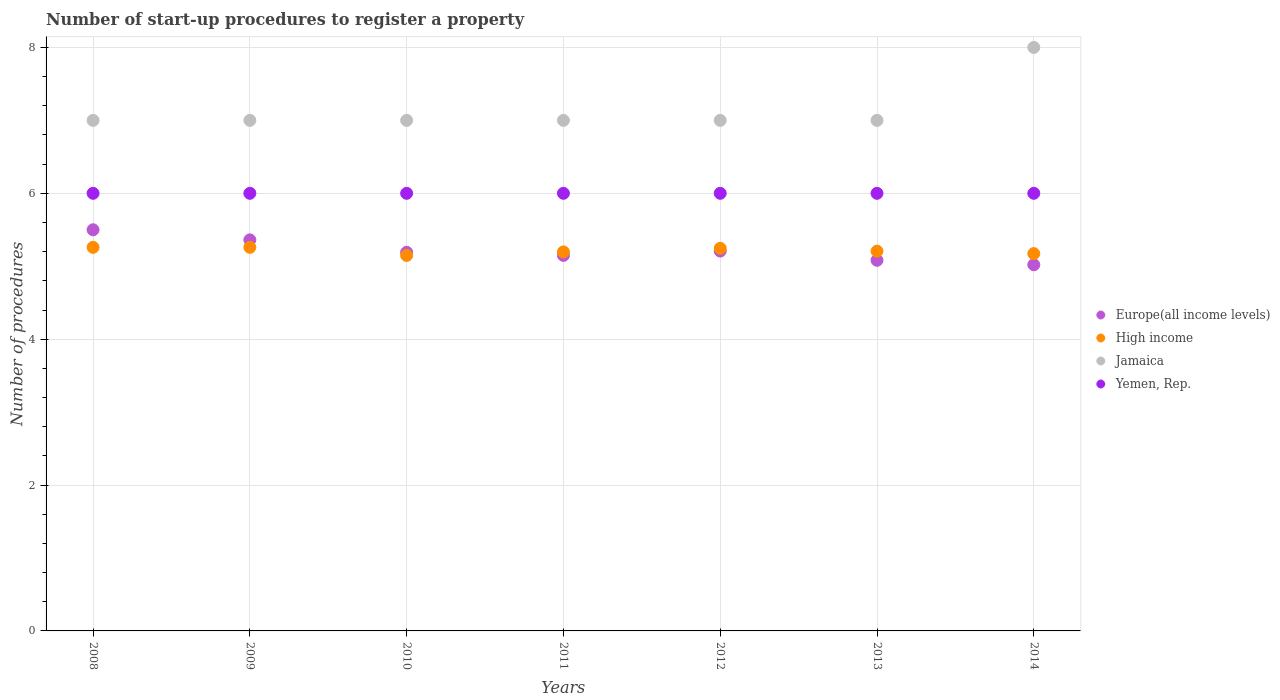What is the number of procedures required to register a property in High income in 2012?
Give a very brief answer. 5.25. Across all years, what is the maximum number of procedures required to register a property in Jamaica?
Your answer should be very brief. 8. Across all years, what is the minimum number of procedures required to register a property in Jamaica?
Your answer should be compact. 7. In which year was the number of procedures required to register a property in Europe(all income levels) maximum?
Your answer should be very brief. 2008. What is the total number of procedures required to register a property in Yemen, Rep. in the graph?
Keep it short and to the point. 42. What is the difference between the number of procedures required to register a property in Yemen, Rep. in 2010 and that in 2013?
Provide a short and direct response. 0. What is the difference between the number of procedures required to register a property in Jamaica in 2014 and the number of procedures required to register a property in High income in 2008?
Provide a short and direct response. 2.74. What is the average number of procedures required to register a property in High income per year?
Ensure brevity in your answer.  5.21. In the year 2009, what is the difference between the number of procedures required to register a property in Europe(all income levels) and number of procedures required to register a property in Jamaica?
Give a very brief answer. -1.64. What is the ratio of the number of procedures required to register a property in High income in 2012 to that in 2014?
Keep it short and to the point. 1.01. Is the number of procedures required to register a property in Yemen, Rep. in 2008 less than that in 2011?
Ensure brevity in your answer.  No. What is the difference between the highest and the second highest number of procedures required to register a property in High income?
Offer a terse response. 0. In how many years, is the number of procedures required to register a property in Europe(all income levels) greater than the average number of procedures required to register a property in Europe(all income levels) taken over all years?
Provide a succinct answer. 2. Does the number of procedures required to register a property in Europe(all income levels) monotonically increase over the years?
Provide a short and direct response. No. How many years are there in the graph?
Ensure brevity in your answer.  7. What is the title of the graph?
Ensure brevity in your answer.  Number of start-up procedures to register a property. Does "Zambia" appear as one of the legend labels in the graph?
Provide a succinct answer. No. What is the label or title of the X-axis?
Offer a terse response. Years. What is the label or title of the Y-axis?
Keep it short and to the point. Number of procedures. What is the Number of procedures in Europe(all income levels) in 2008?
Give a very brief answer. 5.5. What is the Number of procedures in High income in 2008?
Provide a short and direct response. 5.26. What is the Number of procedures in Jamaica in 2008?
Ensure brevity in your answer.  7. What is the Number of procedures of Yemen, Rep. in 2008?
Your response must be concise. 6. What is the Number of procedures in Europe(all income levels) in 2009?
Your response must be concise. 5.36. What is the Number of procedures of High income in 2009?
Keep it short and to the point. 5.26. What is the Number of procedures of Europe(all income levels) in 2010?
Keep it short and to the point. 5.19. What is the Number of procedures in High income in 2010?
Make the answer very short. 5.15. What is the Number of procedures in Europe(all income levels) in 2011?
Your response must be concise. 5.15. What is the Number of procedures in High income in 2011?
Ensure brevity in your answer.  5.2. What is the Number of procedures of Yemen, Rep. in 2011?
Give a very brief answer. 6. What is the Number of procedures of Europe(all income levels) in 2012?
Your answer should be very brief. 5.21. What is the Number of procedures of High income in 2012?
Keep it short and to the point. 5.25. What is the Number of procedures of Jamaica in 2012?
Give a very brief answer. 7. What is the Number of procedures in Yemen, Rep. in 2012?
Offer a very short reply. 6. What is the Number of procedures of Europe(all income levels) in 2013?
Your answer should be very brief. 5.08. What is the Number of procedures in High income in 2013?
Your answer should be compact. 5.21. What is the Number of procedures of Yemen, Rep. in 2013?
Your response must be concise. 6. What is the Number of procedures of Europe(all income levels) in 2014?
Provide a short and direct response. 5.02. What is the Number of procedures in High income in 2014?
Give a very brief answer. 5.17. Across all years, what is the maximum Number of procedures in Europe(all income levels)?
Provide a short and direct response. 5.5. Across all years, what is the maximum Number of procedures of High income?
Provide a short and direct response. 5.26. Across all years, what is the maximum Number of procedures in Yemen, Rep.?
Give a very brief answer. 6. Across all years, what is the minimum Number of procedures of Europe(all income levels)?
Offer a very short reply. 5.02. Across all years, what is the minimum Number of procedures in High income?
Your answer should be compact. 5.15. Across all years, what is the minimum Number of procedures of Yemen, Rep.?
Your answer should be very brief. 6. What is the total Number of procedures of Europe(all income levels) in the graph?
Offer a terse response. 36.51. What is the total Number of procedures of High income in the graph?
Your response must be concise. 36.49. What is the difference between the Number of procedures in Europe(all income levels) in 2008 and that in 2009?
Make the answer very short. 0.14. What is the difference between the Number of procedures in High income in 2008 and that in 2009?
Your answer should be very brief. 0. What is the difference between the Number of procedures of Jamaica in 2008 and that in 2009?
Make the answer very short. 0. What is the difference between the Number of procedures in Europe(all income levels) in 2008 and that in 2010?
Ensure brevity in your answer.  0.31. What is the difference between the Number of procedures of High income in 2008 and that in 2010?
Provide a succinct answer. 0.11. What is the difference between the Number of procedures of Jamaica in 2008 and that in 2010?
Provide a succinct answer. 0. What is the difference between the Number of procedures in Yemen, Rep. in 2008 and that in 2010?
Offer a very short reply. 0. What is the difference between the Number of procedures in Europe(all income levels) in 2008 and that in 2011?
Make the answer very short. 0.35. What is the difference between the Number of procedures of High income in 2008 and that in 2011?
Ensure brevity in your answer.  0.06. What is the difference between the Number of procedures of Yemen, Rep. in 2008 and that in 2011?
Ensure brevity in your answer.  0. What is the difference between the Number of procedures of Europe(all income levels) in 2008 and that in 2012?
Give a very brief answer. 0.29. What is the difference between the Number of procedures in High income in 2008 and that in 2012?
Provide a succinct answer. 0.01. What is the difference between the Number of procedures of Yemen, Rep. in 2008 and that in 2012?
Ensure brevity in your answer.  0. What is the difference between the Number of procedures of Europe(all income levels) in 2008 and that in 2013?
Your response must be concise. 0.42. What is the difference between the Number of procedures of High income in 2008 and that in 2013?
Make the answer very short. 0.05. What is the difference between the Number of procedures of Jamaica in 2008 and that in 2013?
Your answer should be compact. 0. What is the difference between the Number of procedures of Yemen, Rep. in 2008 and that in 2013?
Ensure brevity in your answer.  0. What is the difference between the Number of procedures in Europe(all income levels) in 2008 and that in 2014?
Your answer should be very brief. 0.48. What is the difference between the Number of procedures in High income in 2008 and that in 2014?
Make the answer very short. 0.09. What is the difference between the Number of procedures of Jamaica in 2008 and that in 2014?
Offer a terse response. -1. What is the difference between the Number of procedures in Yemen, Rep. in 2008 and that in 2014?
Provide a succinct answer. 0. What is the difference between the Number of procedures of Europe(all income levels) in 2009 and that in 2010?
Your response must be concise. 0.17. What is the difference between the Number of procedures of High income in 2009 and that in 2010?
Your answer should be very brief. 0.11. What is the difference between the Number of procedures of Jamaica in 2009 and that in 2010?
Provide a succinct answer. 0. What is the difference between the Number of procedures of Yemen, Rep. in 2009 and that in 2010?
Make the answer very short. 0. What is the difference between the Number of procedures in Europe(all income levels) in 2009 and that in 2011?
Offer a very short reply. 0.21. What is the difference between the Number of procedures of High income in 2009 and that in 2011?
Make the answer very short. 0.06. What is the difference between the Number of procedures of Jamaica in 2009 and that in 2011?
Provide a short and direct response. 0. What is the difference between the Number of procedures of Europe(all income levels) in 2009 and that in 2012?
Provide a succinct answer. 0.15. What is the difference between the Number of procedures of High income in 2009 and that in 2012?
Provide a short and direct response. 0.01. What is the difference between the Number of procedures in Yemen, Rep. in 2009 and that in 2012?
Provide a short and direct response. 0. What is the difference between the Number of procedures in Europe(all income levels) in 2009 and that in 2013?
Offer a very short reply. 0.28. What is the difference between the Number of procedures of High income in 2009 and that in 2013?
Your answer should be compact. 0.05. What is the difference between the Number of procedures in Europe(all income levels) in 2009 and that in 2014?
Your answer should be very brief. 0.34. What is the difference between the Number of procedures in High income in 2009 and that in 2014?
Keep it short and to the point. 0.09. What is the difference between the Number of procedures of Yemen, Rep. in 2009 and that in 2014?
Your response must be concise. 0. What is the difference between the Number of procedures in Europe(all income levels) in 2010 and that in 2011?
Your answer should be compact. 0.04. What is the difference between the Number of procedures of High income in 2010 and that in 2011?
Offer a terse response. -0.05. What is the difference between the Number of procedures of Yemen, Rep. in 2010 and that in 2011?
Provide a succinct answer. 0. What is the difference between the Number of procedures of Europe(all income levels) in 2010 and that in 2012?
Your answer should be compact. -0.02. What is the difference between the Number of procedures in High income in 2010 and that in 2012?
Ensure brevity in your answer.  -0.1. What is the difference between the Number of procedures of Yemen, Rep. in 2010 and that in 2012?
Provide a short and direct response. 0. What is the difference between the Number of procedures of Europe(all income levels) in 2010 and that in 2013?
Make the answer very short. 0.11. What is the difference between the Number of procedures in High income in 2010 and that in 2013?
Provide a short and direct response. -0.06. What is the difference between the Number of procedures of Jamaica in 2010 and that in 2013?
Offer a very short reply. 0. What is the difference between the Number of procedures in Yemen, Rep. in 2010 and that in 2013?
Keep it short and to the point. 0. What is the difference between the Number of procedures in Europe(all income levels) in 2010 and that in 2014?
Offer a terse response. 0.17. What is the difference between the Number of procedures in High income in 2010 and that in 2014?
Give a very brief answer. -0.03. What is the difference between the Number of procedures of Yemen, Rep. in 2010 and that in 2014?
Keep it short and to the point. 0. What is the difference between the Number of procedures of Europe(all income levels) in 2011 and that in 2012?
Your answer should be very brief. -0.06. What is the difference between the Number of procedures of High income in 2011 and that in 2012?
Provide a succinct answer. -0.05. What is the difference between the Number of procedures of Europe(all income levels) in 2011 and that in 2013?
Offer a terse response. 0.07. What is the difference between the Number of procedures in High income in 2011 and that in 2013?
Your answer should be compact. -0.01. What is the difference between the Number of procedures in Yemen, Rep. in 2011 and that in 2013?
Offer a very short reply. 0. What is the difference between the Number of procedures in Europe(all income levels) in 2011 and that in 2014?
Make the answer very short. 0.13. What is the difference between the Number of procedures in High income in 2011 and that in 2014?
Provide a short and direct response. 0.02. What is the difference between the Number of procedures in Jamaica in 2011 and that in 2014?
Provide a short and direct response. -1. What is the difference between the Number of procedures of Yemen, Rep. in 2011 and that in 2014?
Give a very brief answer. 0. What is the difference between the Number of procedures in Europe(all income levels) in 2012 and that in 2013?
Make the answer very short. 0.13. What is the difference between the Number of procedures of High income in 2012 and that in 2013?
Your answer should be very brief. 0.04. What is the difference between the Number of procedures of Yemen, Rep. in 2012 and that in 2013?
Your answer should be compact. 0. What is the difference between the Number of procedures in Europe(all income levels) in 2012 and that in 2014?
Offer a terse response. 0.19. What is the difference between the Number of procedures in High income in 2012 and that in 2014?
Your answer should be very brief. 0.07. What is the difference between the Number of procedures in Europe(all income levels) in 2013 and that in 2014?
Provide a succinct answer. 0.06. What is the difference between the Number of procedures in Yemen, Rep. in 2013 and that in 2014?
Make the answer very short. 0. What is the difference between the Number of procedures of Europe(all income levels) in 2008 and the Number of procedures of High income in 2009?
Ensure brevity in your answer.  0.24. What is the difference between the Number of procedures of Europe(all income levels) in 2008 and the Number of procedures of Jamaica in 2009?
Keep it short and to the point. -1.5. What is the difference between the Number of procedures of High income in 2008 and the Number of procedures of Jamaica in 2009?
Provide a succinct answer. -1.74. What is the difference between the Number of procedures of High income in 2008 and the Number of procedures of Yemen, Rep. in 2009?
Your response must be concise. -0.74. What is the difference between the Number of procedures in Europe(all income levels) in 2008 and the Number of procedures in High income in 2010?
Your answer should be compact. 0.35. What is the difference between the Number of procedures in Europe(all income levels) in 2008 and the Number of procedures in Jamaica in 2010?
Keep it short and to the point. -1.5. What is the difference between the Number of procedures in Europe(all income levels) in 2008 and the Number of procedures in Yemen, Rep. in 2010?
Offer a very short reply. -0.5. What is the difference between the Number of procedures of High income in 2008 and the Number of procedures of Jamaica in 2010?
Offer a very short reply. -1.74. What is the difference between the Number of procedures of High income in 2008 and the Number of procedures of Yemen, Rep. in 2010?
Ensure brevity in your answer.  -0.74. What is the difference between the Number of procedures of Jamaica in 2008 and the Number of procedures of Yemen, Rep. in 2010?
Offer a terse response. 1. What is the difference between the Number of procedures of Europe(all income levels) in 2008 and the Number of procedures of High income in 2011?
Your response must be concise. 0.3. What is the difference between the Number of procedures in Europe(all income levels) in 2008 and the Number of procedures in Jamaica in 2011?
Provide a succinct answer. -1.5. What is the difference between the Number of procedures of Europe(all income levels) in 2008 and the Number of procedures of Yemen, Rep. in 2011?
Offer a very short reply. -0.5. What is the difference between the Number of procedures in High income in 2008 and the Number of procedures in Jamaica in 2011?
Make the answer very short. -1.74. What is the difference between the Number of procedures in High income in 2008 and the Number of procedures in Yemen, Rep. in 2011?
Offer a very short reply. -0.74. What is the difference between the Number of procedures of Europe(all income levels) in 2008 and the Number of procedures of High income in 2012?
Provide a short and direct response. 0.25. What is the difference between the Number of procedures in Europe(all income levels) in 2008 and the Number of procedures in Jamaica in 2012?
Give a very brief answer. -1.5. What is the difference between the Number of procedures in Europe(all income levels) in 2008 and the Number of procedures in Yemen, Rep. in 2012?
Ensure brevity in your answer.  -0.5. What is the difference between the Number of procedures of High income in 2008 and the Number of procedures of Jamaica in 2012?
Offer a very short reply. -1.74. What is the difference between the Number of procedures in High income in 2008 and the Number of procedures in Yemen, Rep. in 2012?
Make the answer very short. -0.74. What is the difference between the Number of procedures in Jamaica in 2008 and the Number of procedures in Yemen, Rep. in 2012?
Your answer should be compact. 1. What is the difference between the Number of procedures of Europe(all income levels) in 2008 and the Number of procedures of High income in 2013?
Your answer should be compact. 0.29. What is the difference between the Number of procedures in Europe(all income levels) in 2008 and the Number of procedures in Yemen, Rep. in 2013?
Your response must be concise. -0.5. What is the difference between the Number of procedures of High income in 2008 and the Number of procedures of Jamaica in 2013?
Ensure brevity in your answer.  -1.74. What is the difference between the Number of procedures in High income in 2008 and the Number of procedures in Yemen, Rep. in 2013?
Provide a succinct answer. -0.74. What is the difference between the Number of procedures of Jamaica in 2008 and the Number of procedures of Yemen, Rep. in 2013?
Ensure brevity in your answer.  1. What is the difference between the Number of procedures in Europe(all income levels) in 2008 and the Number of procedures in High income in 2014?
Keep it short and to the point. 0.33. What is the difference between the Number of procedures of Europe(all income levels) in 2008 and the Number of procedures of Yemen, Rep. in 2014?
Your response must be concise. -0.5. What is the difference between the Number of procedures in High income in 2008 and the Number of procedures in Jamaica in 2014?
Offer a terse response. -2.74. What is the difference between the Number of procedures in High income in 2008 and the Number of procedures in Yemen, Rep. in 2014?
Your response must be concise. -0.74. What is the difference between the Number of procedures in Europe(all income levels) in 2009 and the Number of procedures in High income in 2010?
Offer a terse response. 0.21. What is the difference between the Number of procedures in Europe(all income levels) in 2009 and the Number of procedures in Jamaica in 2010?
Provide a succinct answer. -1.64. What is the difference between the Number of procedures of Europe(all income levels) in 2009 and the Number of procedures of Yemen, Rep. in 2010?
Keep it short and to the point. -0.64. What is the difference between the Number of procedures in High income in 2009 and the Number of procedures in Jamaica in 2010?
Your answer should be compact. -1.74. What is the difference between the Number of procedures in High income in 2009 and the Number of procedures in Yemen, Rep. in 2010?
Ensure brevity in your answer.  -0.74. What is the difference between the Number of procedures in Europe(all income levels) in 2009 and the Number of procedures in High income in 2011?
Provide a short and direct response. 0.17. What is the difference between the Number of procedures of Europe(all income levels) in 2009 and the Number of procedures of Jamaica in 2011?
Offer a terse response. -1.64. What is the difference between the Number of procedures in Europe(all income levels) in 2009 and the Number of procedures in Yemen, Rep. in 2011?
Give a very brief answer. -0.64. What is the difference between the Number of procedures in High income in 2009 and the Number of procedures in Jamaica in 2011?
Make the answer very short. -1.74. What is the difference between the Number of procedures in High income in 2009 and the Number of procedures in Yemen, Rep. in 2011?
Your response must be concise. -0.74. What is the difference between the Number of procedures in Jamaica in 2009 and the Number of procedures in Yemen, Rep. in 2011?
Offer a terse response. 1. What is the difference between the Number of procedures in Europe(all income levels) in 2009 and the Number of procedures in High income in 2012?
Your answer should be very brief. 0.12. What is the difference between the Number of procedures of Europe(all income levels) in 2009 and the Number of procedures of Jamaica in 2012?
Keep it short and to the point. -1.64. What is the difference between the Number of procedures of Europe(all income levels) in 2009 and the Number of procedures of Yemen, Rep. in 2012?
Your response must be concise. -0.64. What is the difference between the Number of procedures of High income in 2009 and the Number of procedures of Jamaica in 2012?
Offer a very short reply. -1.74. What is the difference between the Number of procedures in High income in 2009 and the Number of procedures in Yemen, Rep. in 2012?
Keep it short and to the point. -0.74. What is the difference between the Number of procedures in Jamaica in 2009 and the Number of procedures in Yemen, Rep. in 2012?
Offer a very short reply. 1. What is the difference between the Number of procedures of Europe(all income levels) in 2009 and the Number of procedures of High income in 2013?
Your answer should be compact. 0.15. What is the difference between the Number of procedures in Europe(all income levels) in 2009 and the Number of procedures in Jamaica in 2013?
Offer a terse response. -1.64. What is the difference between the Number of procedures of Europe(all income levels) in 2009 and the Number of procedures of Yemen, Rep. in 2013?
Provide a succinct answer. -0.64. What is the difference between the Number of procedures of High income in 2009 and the Number of procedures of Jamaica in 2013?
Your answer should be very brief. -1.74. What is the difference between the Number of procedures in High income in 2009 and the Number of procedures in Yemen, Rep. in 2013?
Your response must be concise. -0.74. What is the difference between the Number of procedures in Jamaica in 2009 and the Number of procedures in Yemen, Rep. in 2013?
Offer a very short reply. 1. What is the difference between the Number of procedures of Europe(all income levels) in 2009 and the Number of procedures of High income in 2014?
Give a very brief answer. 0.19. What is the difference between the Number of procedures in Europe(all income levels) in 2009 and the Number of procedures in Jamaica in 2014?
Your answer should be very brief. -2.64. What is the difference between the Number of procedures of Europe(all income levels) in 2009 and the Number of procedures of Yemen, Rep. in 2014?
Make the answer very short. -0.64. What is the difference between the Number of procedures in High income in 2009 and the Number of procedures in Jamaica in 2014?
Make the answer very short. -2.74. What is the difference between the Number of procedures of High income in 2009 and the Number of procedures of Yemen, Rep. in 2014?
Your response must be concise. -0.74. What is the difference between the Number of procedures in Europe(all income levels) in 2010 and the Number of procedures in High income in 2011?
Your answer should be compact. -0. What is the difference between the Number of procedures in Europe(all income levels) in 2010 and the Number of procedures in Jamaica in 2011?
Your response must be concise. -1.81. What is the difference between the Number of procedures of Europe(all income levels) in 2010 and the Number of procedures of Yemen, Rep. in 2011?
Keep it short and to the point. -0.81. What is the difference between the Number of procedures of High income in 2010 and the Number of procedures of Jamaica in 2011?
Give a very brief answer. -1.85. What is the difference between the Number of procedures of High income in 2010 and the Number of procedures of Yemen, Rep. in 2011?
Ensure brevity in your answer.  -0.85. What is the difference between the Number of procedures of Jamaica in 2010 and the Number of procedures of Yemen, Rep. in 2011?
Your answer should be very brief. 1. What is the difference between the Number of procedures in Europe(all income levels) in 2010 and the Number of procedures in High income in 2012?
Offer a very short reply. -0.05. What is the difference between the Number of procedures of Europe(all income levels) in 2010 and the Number of procedures of Jamaica in 2012?
Give a very brief answer. -1.81. What is the difference between the Number of procedures of Europe(all income levels) in 2010 and the Number of procedures of Yemen, Rep. in 2012?
Offer a very short reply. -0.81. What is the difference between the Number of procedures in High income in 2010 and the Number of procedures in Jamaica in 2012?
Ensure brevity in your answer.  -1.85. What is the difference between the Number of procedures in High income in 2010 and the Number of procedures in Yemen, Rep. in 2012?
Keep it short and to the point. -0.85. What is the difference between the Number of procedures in Jamaica in 2010 and the Number of procedures in Yemen, Rep. in 2012?
Give a very brief answer. 1. What is the difference between the Number of procedures in Europe(all income levels) in 2010 and the Number of procedures in High income in 2013?
Keep it short and to the point. -0.02. What is the difference between the Number of procedures in Europe(all income levels) in 2010 and the Number of procedures in Jamaica in 2013?
Provide a short and direct response. -1.81. What is the difference between the Number of procedures of Europe(all income levels) in 2010 and the Number of procedures of Yemen, Rep. in 2013?
Offer a very short reply. -0.81. What is the difference between the Number of procedures of High income in 2010 and the Number of procedures of Jamaica in 2013?
Keep it short and to the point. -1.85. What is the difference between the Number of procedures in High income in 2010 and the Number of procedures in Yemen, Rep. in 2013?
Your answer should be very brief. -0.85. What is the difference between the Number of procedures of Jamaica in 2010 and the Number of procedures of Yemen, Rep. in 2013?
Offer a very short reply. 1. What is the difference between the Number of procedures in Europe(all income levels) in 2010 and the Number of procedures in High income in 2014?
Keep it short and to the point. 0.02. What is the difference between the Number of procedures of Europe(all income levels) in 2010 and the Number of procedures of Jamaica in 2014?
Your answer should be very brief. -2.81. What is the difference between the Number of procedures of Europe(all income levels) in 2010 and the Number of procedures of Yemen, Rep. in 2014?
Give a very brief answer. -0.81. What is the difference between the Number of procedures in High income in 2010 and the Number of procedures in Jamaica in 2014?
Your response must be concise. -2.85. What is the difference between the Number of procedures in High income in 2010 and the Number of procedures in Yemen, Rep. in 2014?
Offer a very short reply. -0.85. What is the difference between the Number of procedures of Jamaica in 2010 and the Number of procedures of Yemen, Rep. in 2014?
Give a very brief answer. 1. What is the difference between the Number of procedures in Europe(all income levels) in 2011 and the Number of procedures in High income in 2012?
Ensure brevity in your answer.  -0.1. What is the difference between the Number of procedures in Europe(all income levels) in 2011 and the Number of procedures in Jamaica in 2012?
Keep it short and to the point. -1.85. What is the difference between the Number of procedures of Europe(all income levels) in 2011 and the Number of procedures of Yemen, Rep. in 2012?
Keep it short and to the point. -0.85. What is the difference between the Number of procedures of High income in 2011 and the Number of procedures of Jamaica in 2012?
Your response must be concise. -1.8. What is the difference between the Number of procedures in High income in 2011 and the Number of procedures in Yemen, Rep. in 2012?
Provide a succinct answer. -0.8. What is the difference between the Number of procedures in Jamaica in 2011 and the Number of procedures in Yemen, Rep. in 2012?
Provide a short and direct response. 1. What is the difference between the Number of procedures of Europe(all income levels) in 2011 and the Number of procedures of High income in 2013?
Make the answer very short. -0.06. What is the difference between the Number of procedures in Europe(all income levels) in 2011 and the Number of procedures in Jamaica in 2013?
Give a very brief answer. -1.85. What is the difference between the Number of procedures in Europe(all income levels) in 2011 and the Number of procedures in Yemen, Rep. in 2013?
Offer a very short reply. -0.85. What is the difference between the Number of procedures in High income in 2011 and the Number of procedures in Jamaica in 2013?
Keep it short and to the point. -1.8. What is the difference between the Number of procedures of High income in 2011 and the Number of procedures of Yemen, Rep. in 2013?
Provide a succinct answer. -0.8. What is the difference between the Number of procedures of Europe(all income levels) in 2011 and the Number of procedures of High income in 2014?
Give a very brief answer. -0.02. What is the difference between the Number of procedures of Europe(all income levels) in 2011 and the Number of procedures of Jamaica in 2014?
Offer a very short reply. -2.85. What is the difference between the Number of procedures in Europe(all income levels) in 2011 and the Number of procedures in Yemen, Rep. in 2014?
Your response must be concise. -0.85. What is the difference between the Number of procedures of High income in 2011 and the Number of procedures of Jamaica in 2014?
Ensure brevity in your answer.  -2.8. What is the difference between the Number of procedures of High income in 2011 and the Number of procedures of Yemen, Rep. in 2014?
Ensure brevity in your answer.  -0.8. What is the difference between the Number of procedures in Jamaica in 2011 and the Number of procedures in Yemen, Rep. in 2014?
Offer a very short reply. 1. What is the difference between the Number of procedures in Europe(all income levels) in 2012 and the Number of procedures in High income in 2013?
Provide a succinct answer. 0. What is the difference between the Number of procedures in Europe(all income levels) in 2012 and the Number of procedures in Jamaica in 2013?
Ensure brevity in your answer.  -1.79. What is the difference between the Number of procedures in Europe(all income levels) in 2012 and the Number of procedures in Yemen, Rep. in 2013?
Provide a short and direct response. -0.79. What is the difference between the Number of procedures of High income in 2012 and the Number of procedures of Jamaica in 2013?
Offer a terse response. -1.75. What is the difference between the Number of procedures of High income in 2012 and the Number of procedures of Yemen, Rep. in 2013?
Ensure brevity in your answer.  -0.75. What is the difference between the Number of procedures of Europe(all income levels) in 2012 and the Number of procedures of High income in 2014?
Make the answer very short. 0.04. What is the difference between the Number of procedures of Europe(all income levels) in 2012 and the Number of procedures of Jamaica in 2014?
Offer a terse response. -2.79. What is the difference between the Number of procedures in Europe(all income levels) in 2012 and the Number of procedures in Yemen, Rep. in 2014?
Keep it short and to the point. -0.79. What is the difference between the Number of procedures of High income in 2012 and the Number of procedures of Jamaica in 2014?
Provide a succinct answer. -2.75. What is the difference between the Number of procedures in High income in 2012 and the Number of procedures in Yemen, Rep. in 2014?
Offer a very short reply. -0.75. What is the difference between the Number of procedures in Europe(all income levels) in 2013 and the Number of procedures in High income in 2014?
Provide a short and direct response. -0.09. What is the difference between the Number of procedures in Europe(all income levels) in 2013 and the Number of procedures in Jamaica in 2014?
Your answer should be compact. -2.92. What is the difference between the Number of procedures of Europe(all income levels) in 2013 and the Number of procedures of Yemen, Rep. in 2014?
Offer a very short reply. -0.92. What is the difference between the Number of procedures of High income in 2013 and the Number of procedures of Jamaica in 2014?
Offer a terse response. -2.79. What is the difference between the Number of procedures of High income in 2013 and the Number of procedures of Yemen, Rep. in 2014?
Offer a very short reply. -0.79. What is the average Number of procedures in Europe(all income levels) per year?
Give a very brief answer. 5.22. What is the average Number of procedures in High income per year?
Keep it short and to the point. 5.21. What is the average Number of procedures in Jamaica per year?
Make the answer very short. 7.14. In the year 2008, what is the difference between the Number of procedures of Europe(all income levels) and Number of procedures of High income?
Your answer should be very brief. 0.24. In the year 2008, what is the difference between the Number of procedures of High income and Number of procedures of Jamaica?
Provide a short and direct response. -1.74. In the year 2008, what is the difference between the Number of procedures of High income and Number of procedures of Yemen, Rep.?
Offer a terse response. -0.74. In the year 2009, what is the difference between the Number of procedures in Europe(all income levels) and Number of procedures in High income?
Your response must be concise. 0.1. In the year 2009, what is the difference between the Number of procedures of Europe(all income levels) and Number of procedures of Jamaica?
Make the answer very short. -1.64. In the year 2009, what is the difference between the Number of procedures in Europe(all income levels) and Number of procedures in Yemen, Rep.?
Offer a very short reply. -0.64. In the year 2009, what is the difference between the Number of procedures of High income and Number of procedures of Jamaica?
Offer a terse response. -1.74. In the year 2009, what is the difference between the Number of procedures of High income and Number of procedures of Yemen, Rep.?
Your response must be concise. -0.74. In the year 2009, what is the difference between the Number of procedures of Jamaica and Number of procedures of Yemen, Rep.?
Keep it short and to the point. 1. In the year 2010, what is the difference between the Number of procedures of Europe(all income levels) and Number of procedures of High income?
Make the answer very short. 0.04. In the year 2010, what is the difference between the Number of procedures of Europe(all income levels) and Number of procedures of Jamaica?
Offer a very short reply. -1.81. In the year 2010, what is the difference between the Number of procedures in Europe(all income levels) and Number of procedures in Yemen, Rep.?
Provide a succinct answer. -0.81. In the year 2010, what is the difference between the Number of procedures in High income and Number of procedures in Jamaica?
Your response must be concise. -1.85. In the year 2010, what is the difference between the Number of procedures in High income and Number of procedures in Yemen, Rep.?
Your response must be concise. -0.85. In the year 2010, what is the difference between the Number of procedures in Jamaica and Number of procedures in Yemen, Rep.?
Ensure brevity in your answer.  1. In the year 2011, what is the difference between the Number of procedures of Europe(all income levels) and Number of procedures of High income?
Give a very brief answer. -0.05. In the year 2011, what is the difference between the Number of procedures in Europe(all income levels) and Number of procedures in Jamaica?
Provide a short and direct response. -1.85. In the year 2011, what is the difference between the Number of procedures of Europe(all income levels) and Number of procedures of Yemen, Rep.?
Offer a terse response. -0.85. In the year 2011, what is the difference between the Number of procedures in High income and Number of procedures in Jamaica?
Keep it short and to the point. -1.8. In the year 2011, what is the difference between the Number of procedures of High income and Number of procedures of Yemen, Rep.?
Keep it short and to the point. -0.8. In the year 2012, what is the difference between the Number of procedures in Europe(all income levels) and Number of procedures in High income?
Your answer should be compact. -0.04. In the year 2012, what is the difference between the Number of procedures in Europe(all income levels) and Number of procedures in Jamaica?
Your answer should be compact. -1.79. In the year 2012, what is the difference between the Number of procedures of Europe(all income levels) and Number of procedures of Yemen, Rep.?
Provide a short and direct response. -0.79. In the year 2012, what is the difference between the Number of procedures of High income and Number of procedures of Jamaica?
Your answer should be compact. -1.75. In the year 2012, what is the difference between the Number of procedures in High income and Number of procedures in Yemen, Rep.?
Your answer should be very brief. -0.75. In the year 2013, what is the difference between the Number of procedures in Europe(all income levels) and Number of procedures in High income?
Offer a terse response. -0.12. In the year 2013, what is the difference between the Number of procedures of Europe(all income levels) and Number of procedures of Jamaica?
Offer a terse response. -1.92. In the year 2013, what is the difference between the Number of procedures in Europe(all income levels) and Number of procedures in Yemen, Rep.?
Make the answer very short. -0.92. In the year 2013, what is the difference between the Number of procedures of High income and Number of procedures of Jamaica?
Provide a short and direct response. -1.79. In the year 2013, what is the difference between the Number of procedures of High income and Number of procedures of Yemen, Rep.?
Your response must be concise. -0.79. In the year 2013, what is the difference between the Number of procedures of Jamaica and Number of procedures of Yemen, Rep.?
Make the answer very short. 1. In the year 2014, what is the difference between the Number of procedures of Europe(all income levels) and Number of procedures of High income?
Your answer should be compact. -0.15. In the year 2014, what is the difference between the Number of procedures of Europe(all income levels) and Number of procedures of Jamaica?
Offer a very short reply. -2.98. In the year 2014, what is the difference between the Number of procedures of Europe(all income levels) and Number of procedures of Yemen, Rep.?
Your response must be concise. -0.98. In the year 2014, what is the difference between the Number of procedures in High income and Number of procedures in Jamaica?
Your response must be concise. -2.83. In the year 2014, what is the difference between the Number of procedures of High income and Number of procedures of Yemen, Rep.?
Your answer should be compact. -0.83. In the year 2014, what is the difference between the Number of procedures of Jamaica and Number of procedures of Yemen, Rep.?
Provide a short and direct response. 2. What is the ratio of the Number of procedures of Europe(all income levels) in 2008 to that in 2009?
Give a very brief answer. 1.03. What is the ratio of the Number of procedures in High income in 2008 to that in 2009?
Give a very brief answer. 1. What is the ratio of the Number of procedures in Jamaica in 2008 to that in 2009?
Keep it short and to the point. 1. What is the ratio of the Number of procedures in Europe(all income levels) in 2008 to that in 2010?
Provide a short and direct response. 1.06. What is the ratio of the Number of procedures in High income in 2008 to that in 2010?
Offer a terse response. 1.02. What is the ratio of the Number of procedures in Jamaica in 2008 to that in 2010?
Offer a very short reply. 1. What is the ratio of the Number of procedures in Yemen, Rep. in 2008 to that in 2010?
Your response must be concise. 1. What is the ratio of the Number of procedures of Europe(all income levels) in 2008 to that in 2011?
Your answer should be very brief. 1.07. What is the ratio of the Number of procedures in High income in 2008 to that in 2011?
Provide a short and direct response. 1.01. What is the ratio of the Number of procedures of Yemen, Rep. in 2008 to that in 2011?
Offer a very short reply. 1. What is the ratio of the Number of procedures in Europe(all income levels) in 2008 to that in 2012?
Make the answer very short. 1.06. What is the ratio of the Number of procedures in Europe(all income levels) in 2008 to that in 2013?
Keep it short and to the point. 1.08. What is the ratio of the Number of procedures in High income in 2008 to that in 2013?
Offer a very short reply. 1.01. What is the ratio of the Number of procedures in Yemen, Rep. in 2008 to that in 2013?
Offer a terse response. 1. What is the ratio of the Number of procedures of Europe(all income levels) in 2008 to that in 2014?
Keep it short and to the point. 1.1. What is the ratio of the Number of procedures in High income in 2008 to that in 2014?
Your answer should be very brief. 1.02. What is the ratio of the Number of procedures of Jamaica in 2008 to that in 2014?
Ensure brevity in your answer.  0.88. What is the ratio of the Number of procedures in Europe(all income levels) in 2009 to that in 2010?
Provide a short and direct response. 1.03. What is the ratio of the Number of procedures of High income in 2009 to that in 2010?
Keep it short and to the point. 1.02. What is the ratio of the Number of procedures of Yemen, Rep. in 2009 to that in 2010?
Ensure brevity in your answer.  1. What is the ratio of the Number of procedures of Europe(all income levels) in 2009 to that in 2011?
Make the answer very short. 1.04. What is the ratio of the Number of procedures in High income in 2009 to that in 2011?
Make the answer very short. 1.01. What is the ratio of the Number of procedures of Yemen, Rep. in 2009 to that in 2011?
Keep it short and to the point. 1. What is the ratio of the Number of procedures of Europe(all income levels) in 2009 to that in 2012?
Give a very brief answer. 1.03. What is the ratio of the Number of procedures of High income in 2009 to that in 2012?
Keep it short and to the point. 1. What is the ratio of the Number of procedures in Yemen, Rep. in 2009 to that in 2012?
Provide a succinct answer. 1. What is the ratio of the Number of procedures in Europe(all income levels) in 2009 to that in 2013?
Keep it short and to the point. 1.06. What is the ratio of the Number of procedures of Jamaica in 2009 to that in 2013?
Offer a terse response. 1. What is the ratio of the Number of procedures of Yemen, Rep. in 2009 to that in 2013?
Your answer should be very brief. 1. What is the ratio of the Number of procedures in Europe(all income levels) in 2009 to that in 2014?
Your answer should be very brief. 1.07. What is the ratio of the Number of procedures in High income in 2009 to that in 2014?
Your answer should be compact. 1.02. What is the ratio of the Number of procedures of Europe(all income levels) in 2010 to that in 2011?
Offer a terse response. 1.01. What is the ratio of the Number of procedures of Jamaica in 2010 to that in 2011?
Provide a short and direct response. 1. What is the ratio of the Number of procedures in Yemen, Rep. in 2010 to that in 2011?
Provide a short and direct response. 1. What is the ratio of the Number of procedures in Europe(all income levels) in 2010 to that in 2012?
Ensure brevity in your answer.  1. What is the ratio of the Number of procedures of High income in 2010 to that in 2012?
Provide a short and direct response. 0.98. What is the ratio of the Number of procedures of Jamaica in 2010 to that in 2012?
Your answer should be very brief. 1. What is the ratio of the Number of procedures in Yemen, Rep. in 2010 to that in 2012?
Ensure brevity in your answer.  1. What is the ratio of the Number of procedures in Europe(all income levels) in 2010 to that in 2013?
Provide a succinct answer. 1.02. What is the ratio of the Number of procedures of High income in 2010 to that in 2013?
Give a very brief answer. 0.99. What is the ratio of the Number of procedures of Jamaica in 2010 to that in 2013?
Your answer should be compact. 1. What is the ratio of the Number of procedures of Yemen, Rep. in 2010 to that in 2013?
Offer a terse response. 1. What is the ratio of the Number of procedures of Europe(all income levels) in 2010 to that in 2014?
Your answer should be compact. 1.03. What is the ratio of the Number of procedures of High income in 2010 to that in 2014?
Offer a very short reply. 1. What is the ratio of the Number of procedures of Jamaica in 2010 to that in 2014?
Offer a terse response. 0.88. What is the ratio of the Number of procedures in Europe(all income levels) in 2011 to that in 2012?
Provide a short and direct response. 0.99. What is the ratio of the Number of procedures of High income in 2011 to that in 2012?
Make the answer very short. 0.99. What is the ratio of the Number of procedures in Jamaica in 2011 to that in 2012?
Offer a very short reply. 1. What is the ratio of the Number of procedures in Europe(all income levels) in 2011 to that in 2013?
Your response must be concise. 1.01. What is the ratio of the Number of procedures in Yemen, Rep. in 2011 to that in 2013?
Offer a very short reply. 1. What is the ratio of the Number of procedures of Europe(all income levels) in 2011 to that in 2014?
Make the answer very short. 1.03. What is the ratio of the Number of procedures of High income in 2011 to that in 2014?
Provide a succinct answer. 1. What is the ratio of the Number of procedures of Europe(all income levels) in 2012 to that in 2013?
Make the answer very short. 1.02. What is the ratio of the Number of procedures in High income in 2012 to that in 2013?
Keep it short and to the point. 1.01. What is the ratio of the Number of procedures in Jamaica in 2012 to that in 2013?
Your response must be concise. 1. What is the ratio of the Number of procedures in Yemen, Rep. in 2012 to that in 2013?
Provide a short and direct response. 1. What is the ratio of the Number of procedures in Europe(all income levels) in 2012 to that in 2014?
Your response must be concise. 1.04. What is the ratio of the Number of procedures of High income in 2012 to that in 2014?
Offer a very short reply. 1.01. What is the ratio of the Number of procedures in Jamaica in 2012 to that in 2014?
Ensure brevity in your answer.  0.88. What is the ratio of the Number of procedures in Yemen, Rep. in 2012 to that in 2014?
Offer a very short reply. 1. What is the ratio of the Number of procedures in Europe(all income levels) in 2013 to that in 2014?
Provide a succinct answer. 1.01. What is the ratio of the Number of procedures in High income in 2013 to that in 2014?
Your response must be concise. 1.01. What is the difference between the highest and the second highest Number of procedures of Europe(all income levels)?
Your response must be concise. 0.14. What is the difference between the highest and the second highest Number of procedures in High income?
Offer a very short reply. 0. What is the difference between the highest and the second highest Number of procedures in Yemen, Rep.?
Provide a short and direct response. 0. What is the difference between the highest and the lowest Number of procedures in Europe(all income levels)?
Give a very brief answer. 0.48. What is the difference between the highest and the lowest Number of procedures of High income?
Provide a short and direct response. 0.11. What is the difference between the highest and the lowest Number of procedures in Jamaica?
Your response must be concise. 1. 